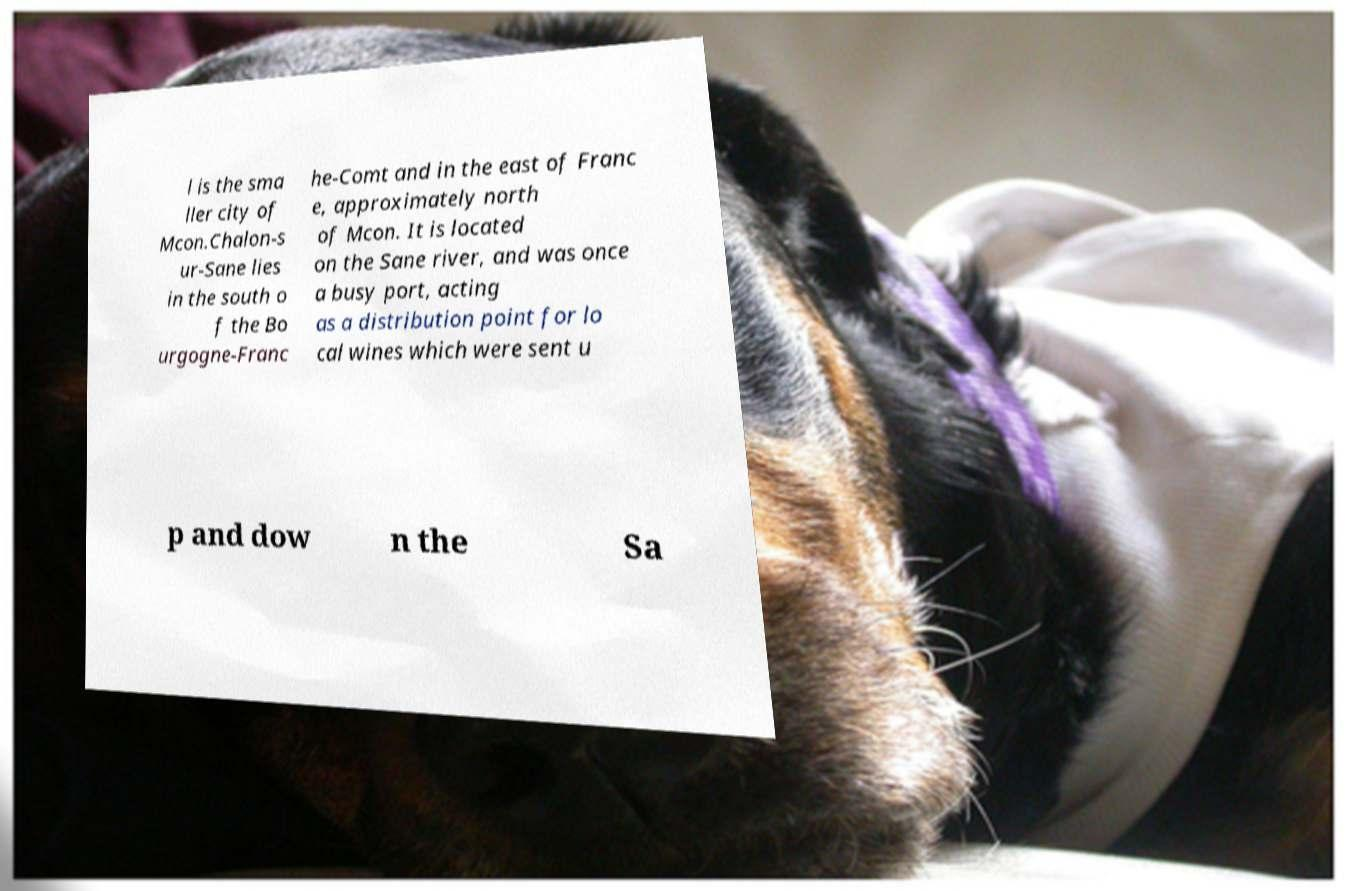I need the written content from this picture converted into text. Can you do that? l is the sma ller city of Mcon.Chalon-s ur-Sane lies in the south o f the Bo urgogne-Franc he-Comt and in the east of Franc e, approximately north of Mcon. It is located on the Sane river, and was once a busy port, acting as a distribution point for lo cal wines which were sent u p and dow n the Sa 